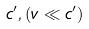Convert formula to latex. <formula><loc_0><loc_0><loc_500><loc_500>c ^ { \prime } , ( v \ll c ^ { \prime } )</formula> 